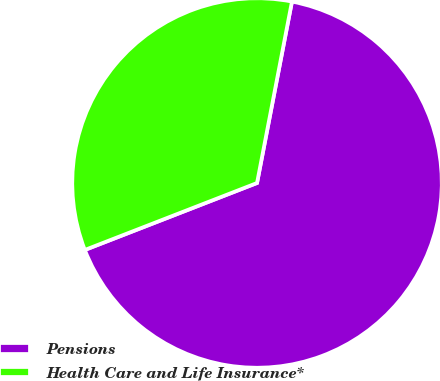Convert chart. <chart><loc_0><loc_0><loc_500><loc_500><pie_chart><fcel>Pensions<fcel>Health Care and Life Insurance*<nl><fcel>66.07%<fcel>33.93%<nl></chart> 